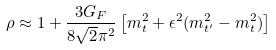Convert formula to latex. <formula><loc_0><loc_0><loc_500><loc_500>\rho \approx 1 + \frac { 3 G _ { F } } { 8 \sqrt { 2 } \pi ^ { 2 } } \left [ m _ { t } ^ { 2 } + \epsilon ^ { 2 } ( m _ { t ^ { \prime } } ^ { 2 } - m _ { t } ^ { 2 } ) \right ]</formula> 